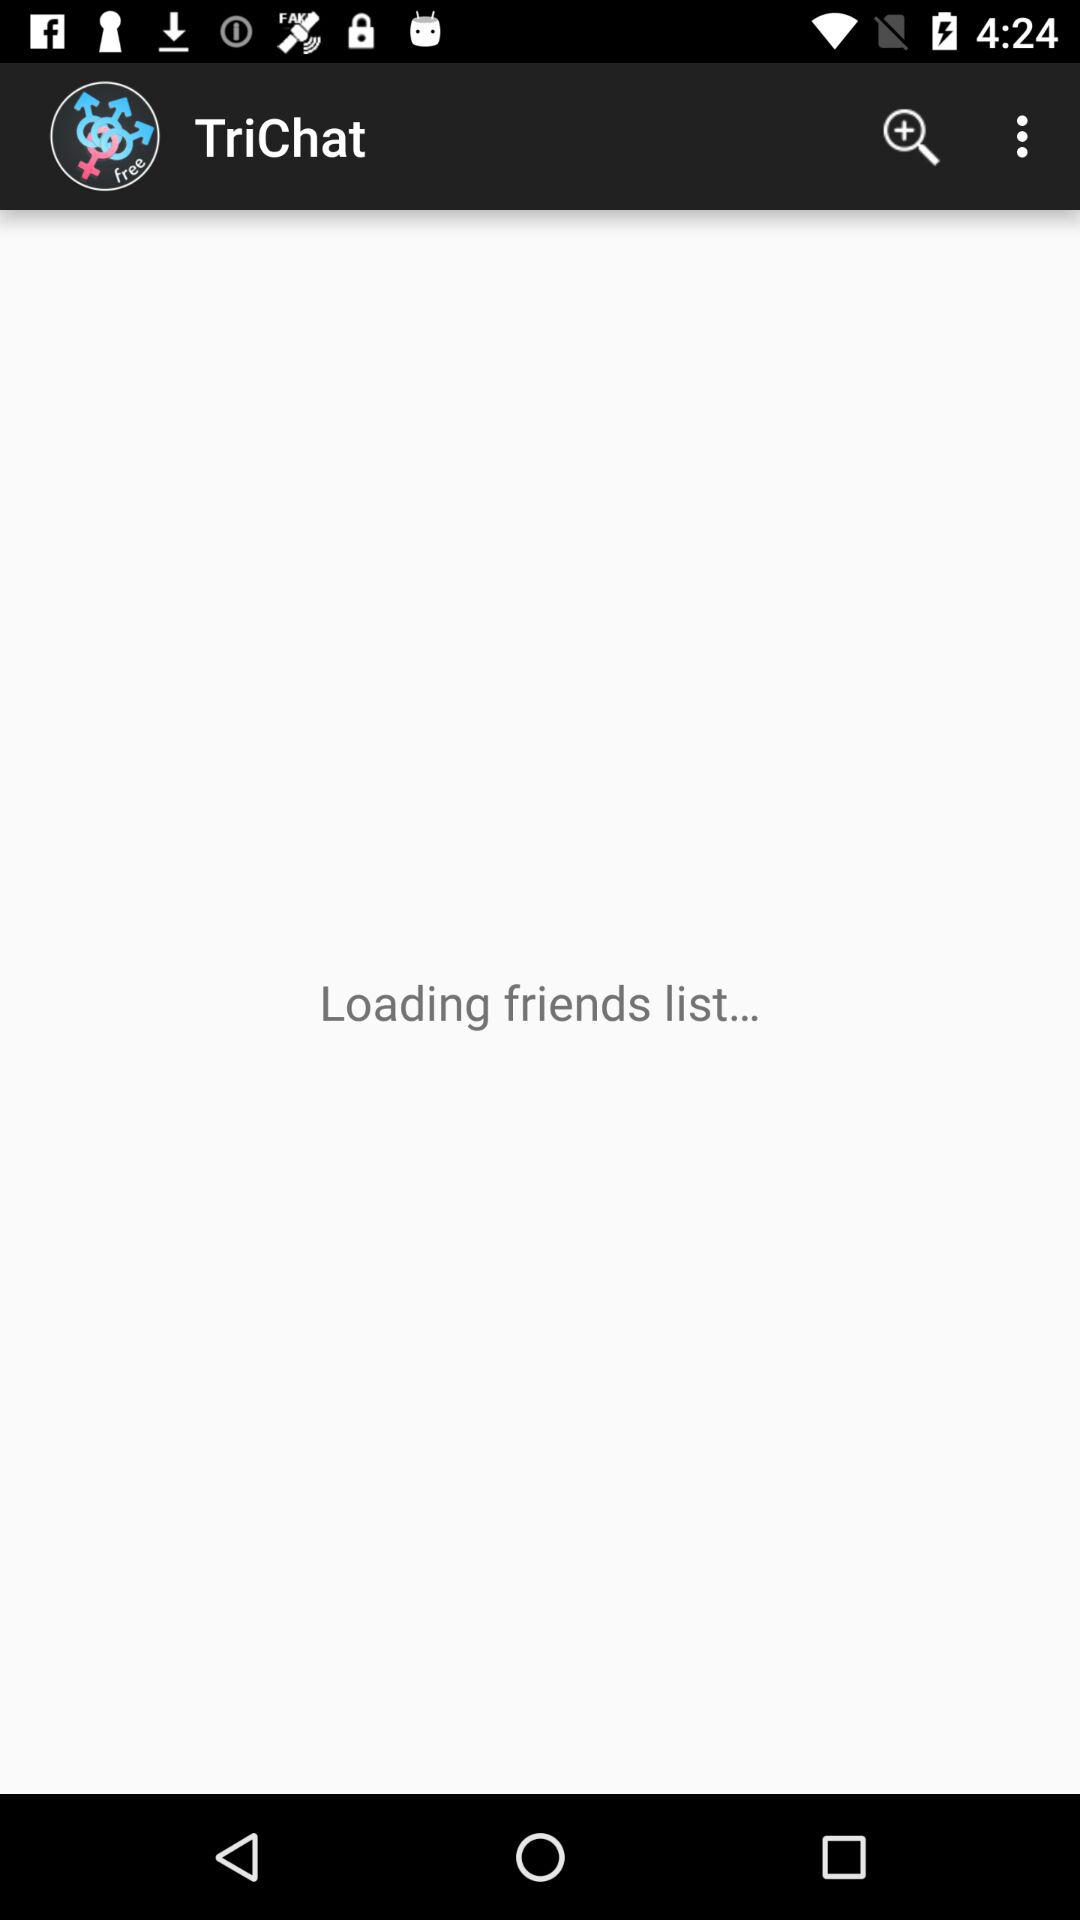What is the app name? The app name is "TriChat". 